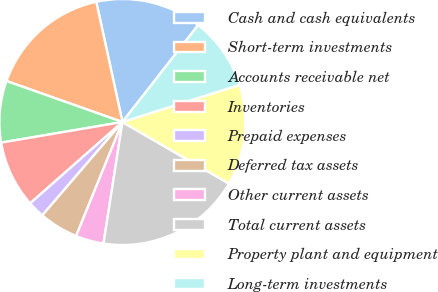<chart> <loc_0><loc_0><loc_500><loc_500><pie_chart><fcel>Cash and cash equivalents<fcel>Short-term investments<fcel>Accounts receivable net<fcel>Inventories<fcel>Prepaid expenses<fcel>Deferred tax assets<fcel>Other current assets<fcel>Total current assets<fcel>Property plant and equipment<fcel>Long-term investments<nl><fcel>13.97%<fcel>16.18%<fcel>8.09%<fcel>8.82%<fcel>2.21%<fcel>5.15%<fcel>3.68%<fcel>19.12%<fcel>13.24%<fcel>9.56%<nl></chart> 